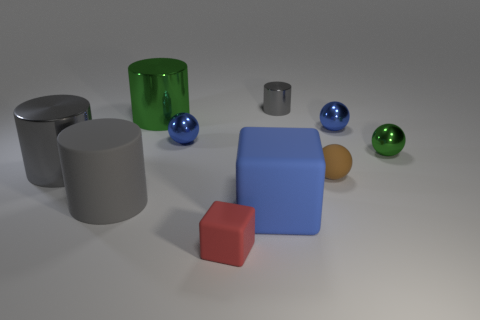Subtract all large green metal cylinders. How many cylinders are left? 3 Subtract all green spheres. How many spheres are left? 3 Subtract 1 cylinders. How many cylinders are left? 3 Subtract all cubes. How many objects are left? 8 Subtract all tiny gray blocks. Subtract all tiny gray metallic things. How many objects are left? 9 Add 1 blue things. How many blue things are left? 4 Add 6 matte balls. How many matte balls exist? 7 Subtract 0 cyan spheres. How many objects are left? 10 Subtract all cyan spheres. Subtract all purple cylinders. How many spheres are left? 4 Subtract all green blocks. How many cyan cylinders are left? 0 